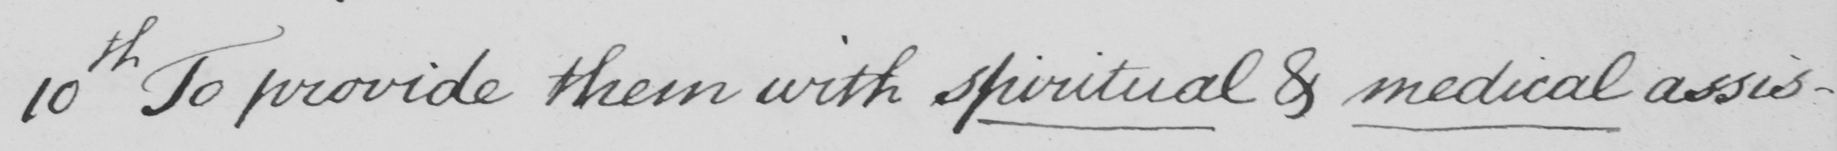What text is written in this handwritten line? 10th To provide them with spiritual & medical assis- 